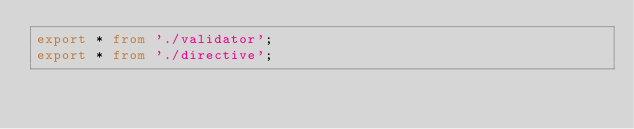Convert code to text. <code><loc_0><loc_0><loc_500><loc_500><_TypeScript_>export * from './validator';
export * from './directive';
</code> 